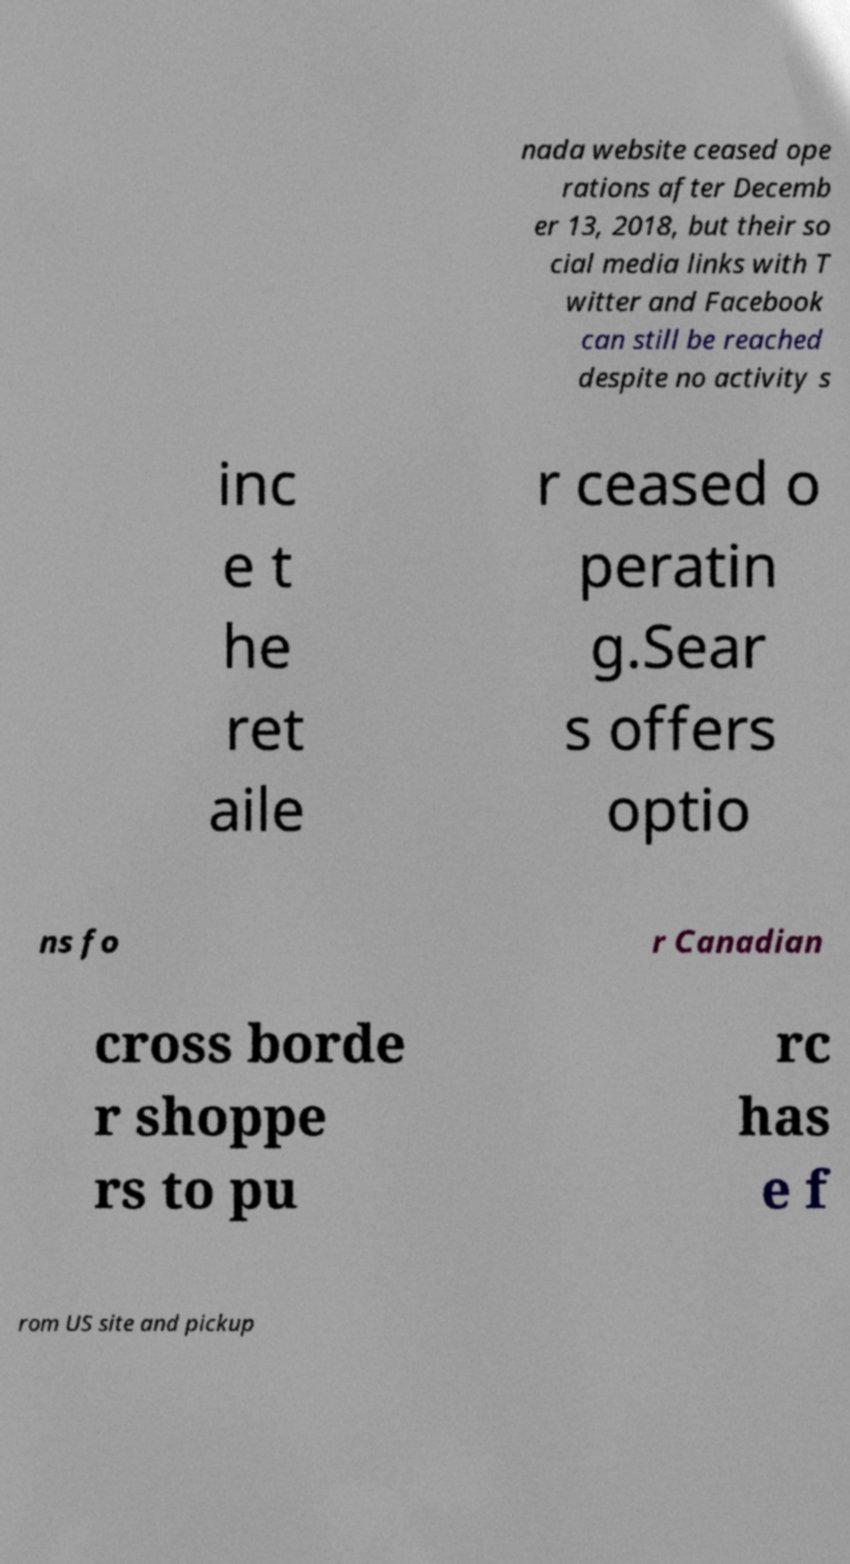Could you extract and type out the text from this image? nada website ceased ope rations after Decemb er 13, 2018, but their so cial media links with T witter and Facebook can still be reached despite no activity s inc e t he ret aile r ceased o peratin g.Sear s offers optio ns fo r Canadian cross borde r shoppe rs to pu rc has e f rom US site and pickup 